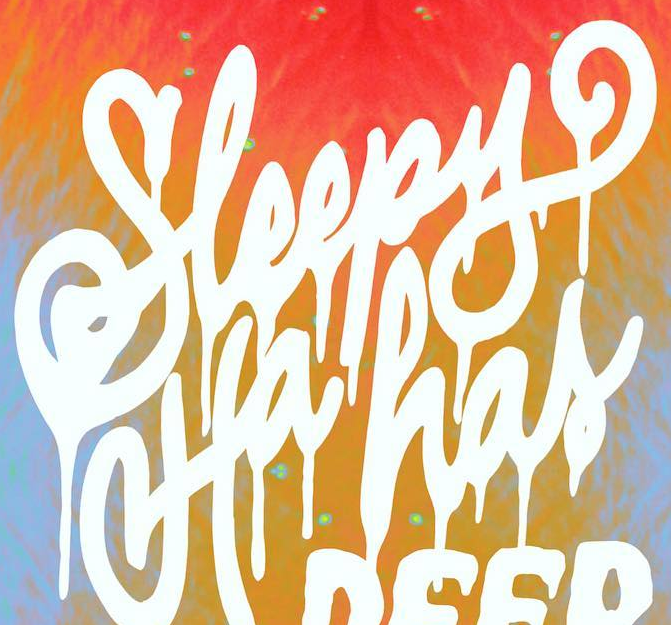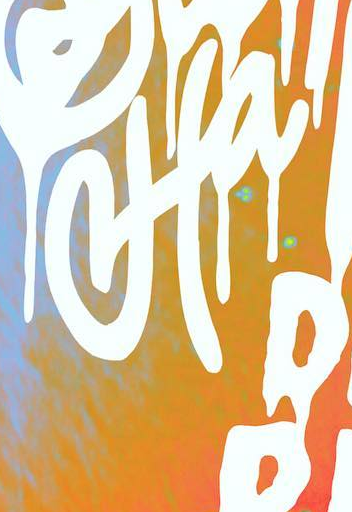Read the text from these images in sequence, separated by a semicolon. Sleepy; Ha 